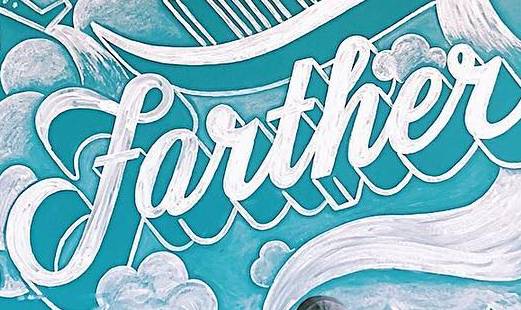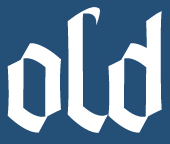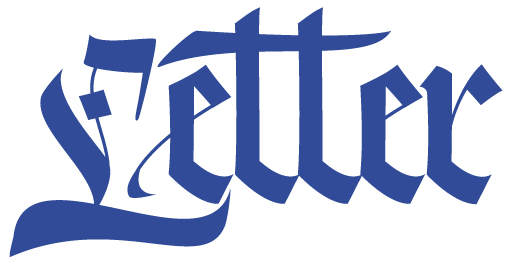What words are shown in these images in order, separated by a semicolon? farther; old; Letter 